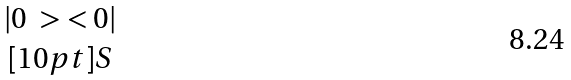<formula> <loc_0><loc_0><loc_500><loc_500>\begin{matrix} | 0 \ > \ < 0 | \\ [ 1 0 p t ] S \end{matrix}</formula> 